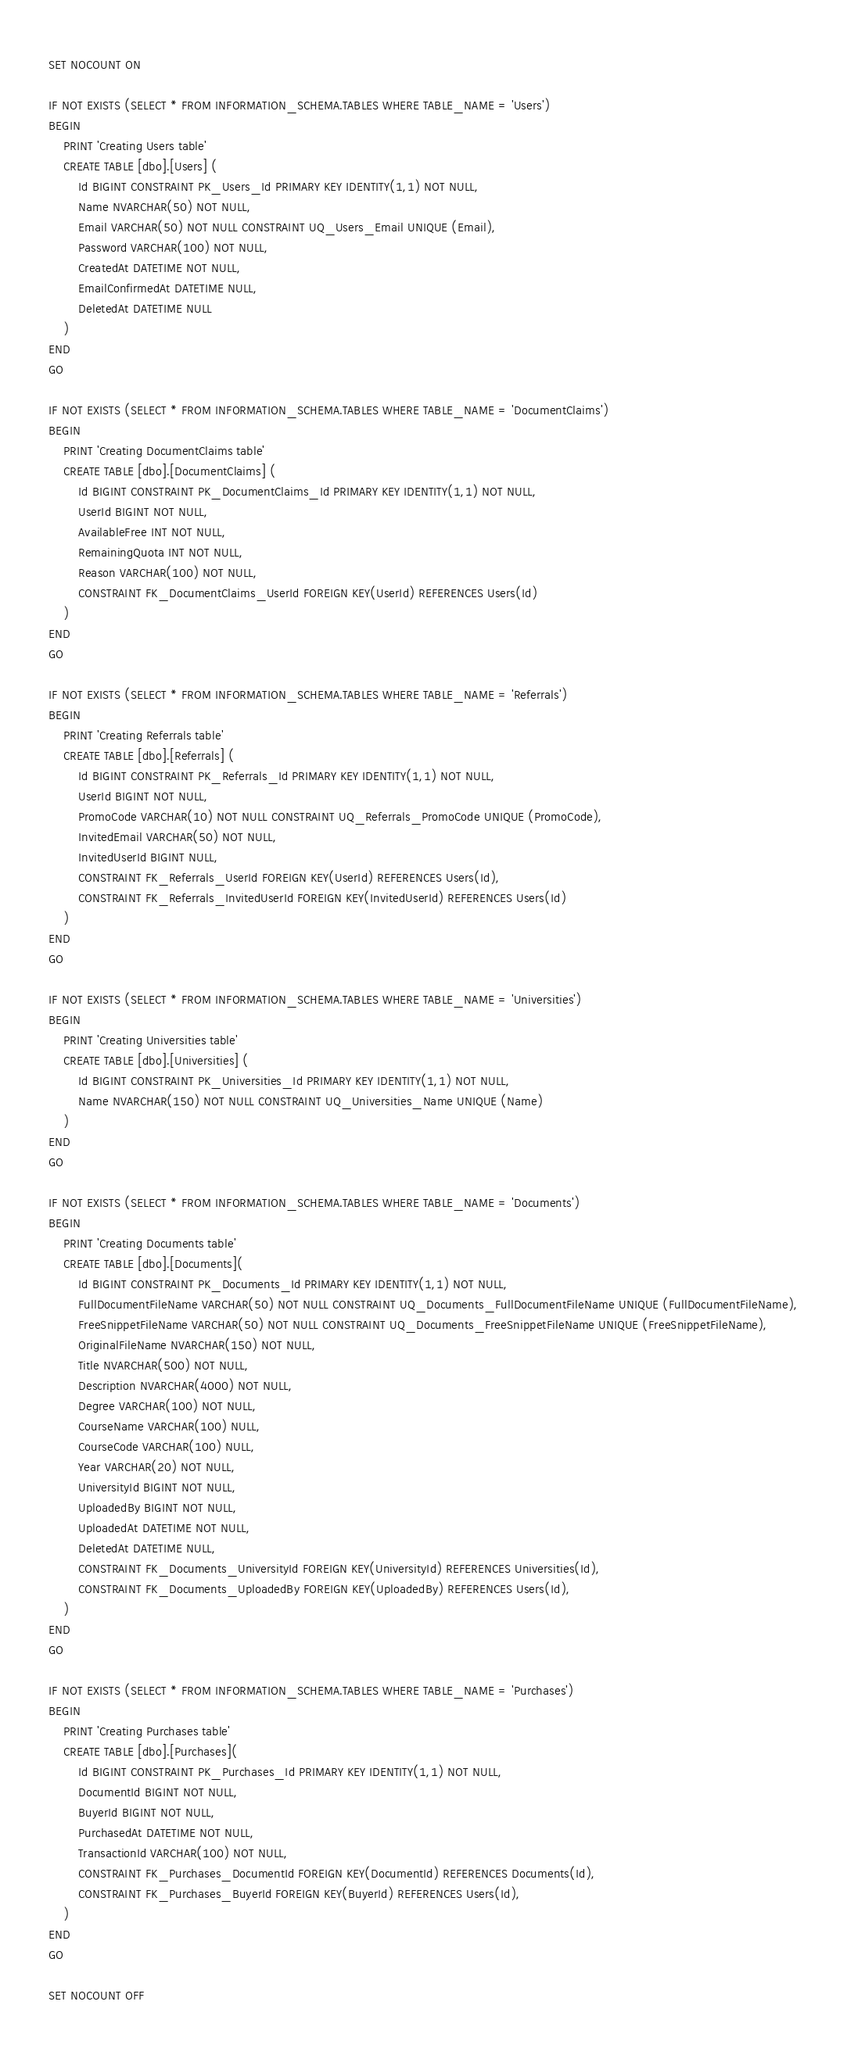<code> <loc_0><loc_0><loc_500><loc_500><_SQL_>SET NOCOUNT ON

IF NOT EXISTS (SELECT * FROM INFORMATION_SCHEMA.TABLES WHERE TABLE_NAME = 'Users')
BEGIN
	PRINT 'Creating Users table'
	CREATE TABLE [dbo].[Users] (
		Id BIGINT CONSTRAINT PK_Users_Id PRIMARY KEY IDENTITY(1,1) NOT NULL,
		Name NVARCHAR(50) NOT NULL,
		Email VARCHAR(50) NOT NULL CONSTRAINT UQ_Users_Email UNIQUE (Email),
		Password VARCHAR(100) NOT NULL,
		CreatedAt DATETIME NOT NULL,
		EmailConfirmedAt DATETIME NULL,
		DeletedAt DATETIME NULL
	)
END
GO

IF NOT EXISTS (SELECT * FROM INFORMATION_SCHEMA.TABLES WHERE TABLE_NAME = 'DocumentClaims')
BEGIN
	PRINT 'Creating DocumentClaims table'
	CREATE TABLE [dbo].[DocumentClaims] (
		Id BIGINT CONSTRAINT PK_DocumentClaims_Id PRIMARY KEY IDENTITY(1,1) NOT NULL,
		UserId BIGINT NOT NULL,
		AvailableFree INT NOT NULL,
		RemainingQuota INT NOT NULL,
		Reason VARCHAR(100) NOT NULL,
		CONSTRAINT FK_DocumentClaims_UserId FOREIGN KEY(UserId) REFERENCES Users(Id)
	)
END
GO

IF NOT EXISTS (SELECT * FROM INFORMATION_SCHEMA.TABLES WHERE TABLE_NAME = 'Referrals')
BEGIN
	PRINT 'Creating Referrals table'
	CREATE TABLE [dbo].[Referrals] (
		Id BIGINT CONSTRAINT PK_Referrals_Id PRIMARY KEY IDENTITY(1,1) NOT NULL,
		UserId BIGINT NOT NULL,
		PromoCode VARCHAR(10) NOT NULL CONSTRAINT UQ_Referrals_PromoCode UNIQUE (PromoCode),
		InvitedEmail VARCHAR(50) NOT NULL,
		InvitedUserId BIGINT NULL,
		CONSTRAINT FK_Referrals_UserId FOREIGN KEY(UserId) REFERENCES Users(Id),
		CONSTRAINT FK_Referrals_InvitedUserId FOREIGN KEY(InvitedUserId) REFERENCES Users(Id)
	)
END
GO

IF NOT EXISTS (SELECT * FROM INFORMATION_SCHEMA.TABLES WHERE TABLE_NAME = 'Universities')
BEGIN
	PRINT 'Creating Universities table'
	CREATE TABLE [dbo].[Universities] (
		Id BIGINT CONSTRAINT PK_Universities_Id PRIMARY KEY IDENTITY(1,1) NOT NULL,
		Name NVARCHAR(150) NOT NULL CONSTRAINT UQ_Universities_Name UNIQUE (Name)
	)
END
GO

IF NOT EXISTS (SELECT * FROM INFORMATION_SCHEMA.TABLES WHERE TABLE_NAME = 'Documents')
BEGIN
	PRINT 'Creating Documents table'
	CREATE TABLE [dbo].[Documents](
		Id BIGINT CONSTRAINT PK_Documents_Id PRIMARY KEY IDENTITY(1,1) NOT NULL,
		FullDocumentFileName VARCHAR(50) NOT NULL CONSTRAINT UQ_Documents_FullDocumentFileName UNIQUE (FullDocumentFileName),
		FreeSnippetFileName VARCHAR(50) NOT NULL CONSTRAINT UQ_Documents_FreeSnippetFileName UNIQUE (FreeSnippetFileName),
		OriginalFileName NVARCHAR(150) NOT NULL,
		Title NVARCHAR(500) NOT NULL,
		Description NVARCHAR(4000) NOT NULL,
		Degree VARCHAR(100) NOT NULL,
		CourseName VARCHAR(100) NULL,
		CourseCode VARCHAR(100) NULL,
		Year VARCHAR(20) NOT NULL,
		UniversityId BIGINT NOT NULL,
		UploadedBy BIGINT NOT NULL,
		UploadedAt DATETIME NOT NULL,
		DeletedAt DATETIME NULL,
		CONSTRAINT FK_Documents_UniversityId FOREIGN KEY(UniversityId) REFERENCES Universities(Id),
		CONSTRAINT FK_Documents_UploadedBy FOREIGN KEY(UploadedBy) REFERENCES Users(Id),
	)
END
GO

IF NOT EXISTS (SELECT * FROM INFORMATION_SCHEMA.TABLES WHERE TABLE_NAME = 'Purchases')
BEGIN
	PRINT 'Creating Purchases table'
	CREATE TABLE [dbo].[Purchases](
		Id BIGINT CONSTRAINT PK_Purchases_Id PRIMARY KEY IDENTITY(1,1) NOT NULL,
		DocumentId BIGINT NOT NULL,
		BuyerId BIGINT NOT NULL,
		PurchasedAt DATETIME NOT NULL,
		TransactionId VARCHAR(100) NOT NULL,
		CONSTRAINT FK_Purchases_DocumentId FOREIGN KEY(DocumentId) REFERENCES Documents(Id),
		CONSTRAINT FK_Purchases_BuyerId FOREIGN KEY(BuyerId) REFERENCES Users(Id),
	)
END
GO

SET NOCOUNT OFF</code> 